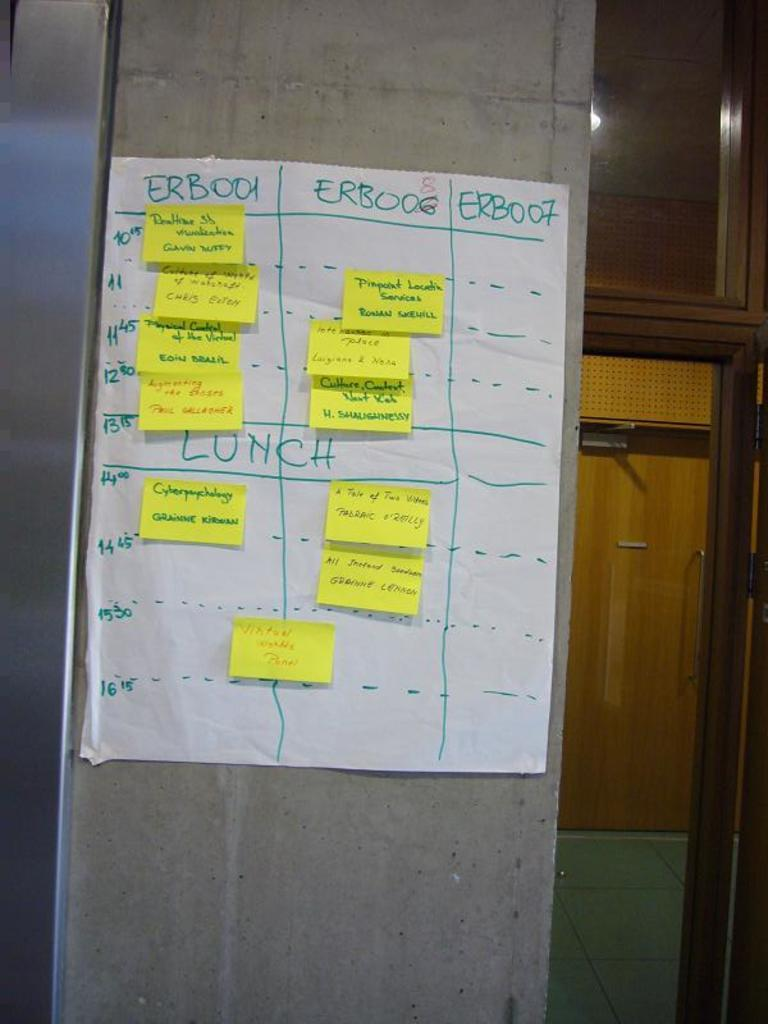What is attached to the wall in the image? There is a paper attached to a wall in the image. What is on the attached paper? There are papers on the attached paper. What can be seen in the background of the image? There is a door and a floor visible in the background. How does the island help the porter in the image? There is no island or porter present in the image. 